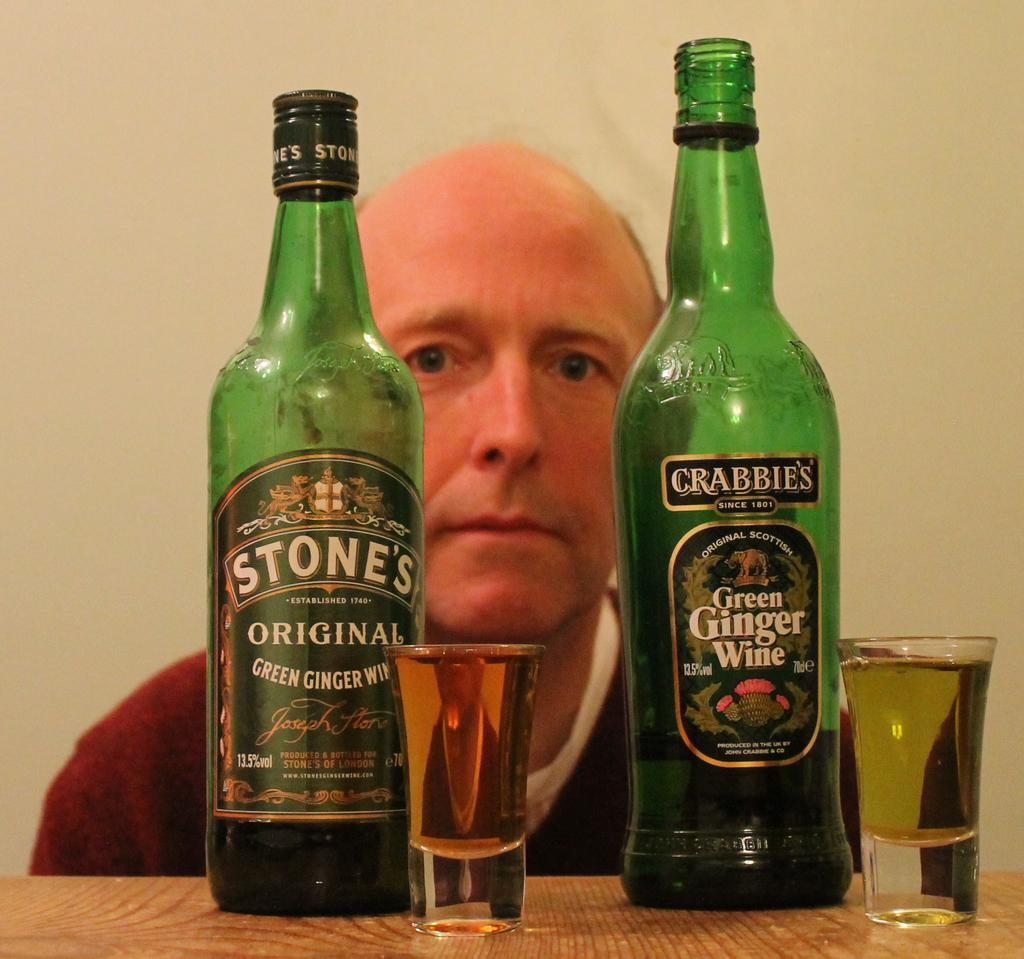<image>
Render a clear and concise summary of the photo. two bottles of green ginger wine by different manufacturers 